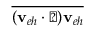Convert formula to latex. <formula><loc_0><loc_0><loc_500><loc_500>\overline { { ( v _ { e h } \cdot \triangle d o w n ) v _ { e h } } }</formula> 